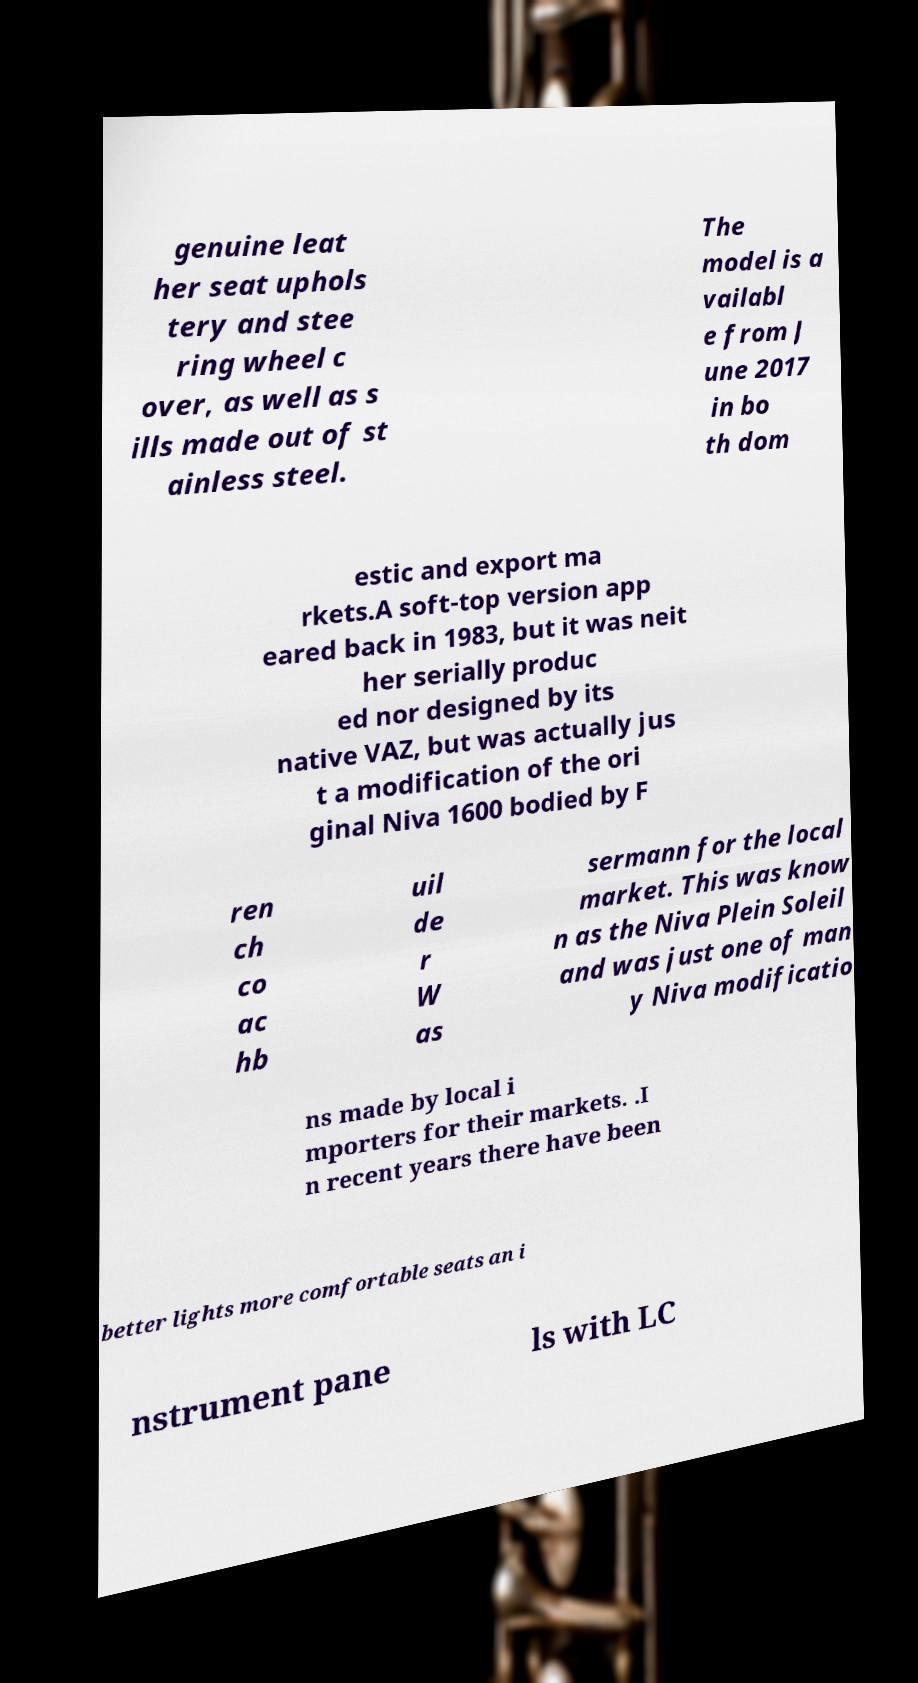What messages or text are displayed in this image? I need them in a readable, typed format. genuine leat her seat uphols tery and stee ring wheel c over, as well as s ills made out of st ainless steel. The model is a vailabl e from J une 2017 in bo th dom estic and export ma rkets.A soft-top version app eared back in 1983, but it was neit her serially produc ed nor designed by its native VAZ, but was actually jus t a modification of the ori ginal Niva 1600 bodied by F ren ch co ac hb uil de r W as sermann for the local market. This was know n as the Niva Plein Soleil and was just one of man y Niva modificatio ns made by local i mporters for their markets. .I n recent years there have been better lights more comfortable seats an i nstrument pane ls with LC 